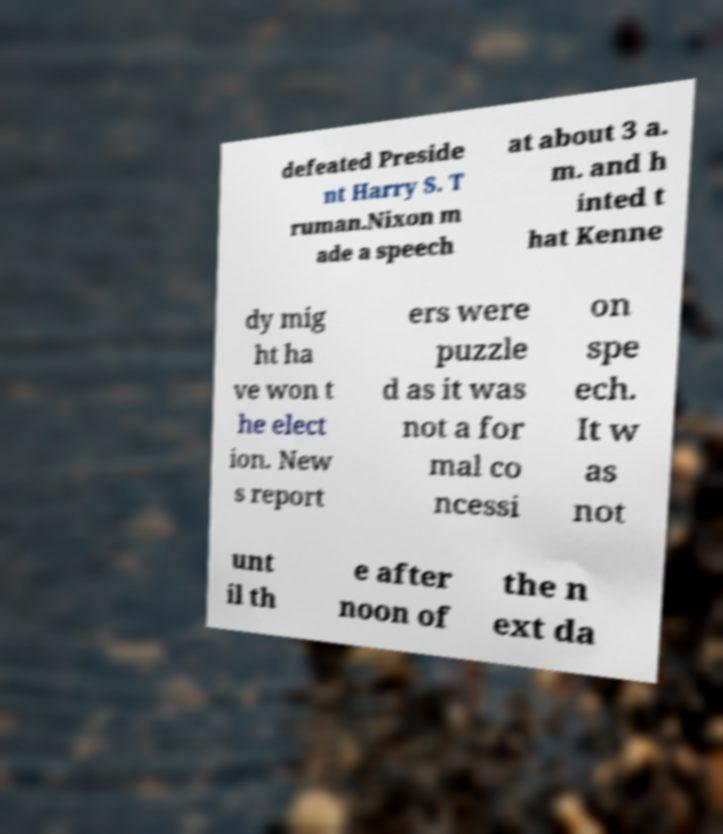I need the written content from this picture converted into text. Can you do that? defeated Preside nt Harry S. T ruman.Nixon m ade a speech at about 3 a. m. and h inted t hat Kenne dy mig ht ha ve won t he elect ion. New s report ers were puzzle d as it was not a for mal co ncessi on spe ech. It w as not unt il th e after noon of the n ext da 